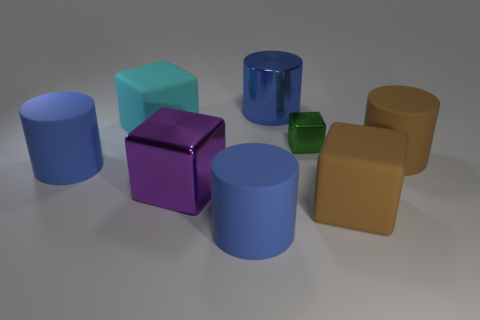There is a cyan cube that is the same material as the large brown block; what is its size?
Provide a succinct answer. Large. What number of tiny metallic cubes have the same color as the large shiny block?
Offer a terse response. 0. Are there any tiny balls?
Your answer should be very brief. No. There is a cyan rubber object; is its shape the same as the blue rubber thing to the left of the cyan matte thing?
Provide a short and direct response. No. What color is the matte cube that is to the right of the large metallic object left of the object that is behind the cyan matte thing?
Give a very brief answer. Brown. Are there any large blue objects on the right side of the tiny green cube?
Provide a short and direct response. No. Is there a gray ball made of the same material as the green cube?
Provide a succinct answer. No. The tiny metal thing has what color?
Ensure brevity in your answer.  Green. There is a shiny object on the right side of the shiny cylinder; is it the same shape as the large cyan matte thing?
Provide a short and direct response. Yes. What is the shape of the big brown thing in front of the large purple cube to the left of the big cylinder behind the big cyan thing?
Offer a terse response. Cube. 